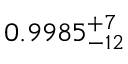Convert formula to latex. <formula><loc_0><loc_0><loc_500><loc_500>0 . 9 9 8 5 _ { - 1 2 } ^ { + 7 }</formula> 